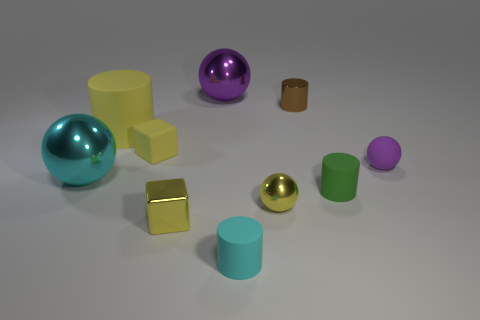The tiny metal block is what color?
Offer a terse response. Yellow. Is there a tiny object of the same color as the rubber block?
Give a very brief answer. Yes. The big metal thing that is on the right side of the metal object that is on the left side of the yellow block that is behind the large cyan metal ball is what shape?
Ensure brevity in your answer.  Sphere. What is the material of the object that is to the right of the small green rubber object?
Ensure brevity in your answer.  Rubber. There is a shiny ball that is right of the large thing that is behind the brown metal cylinder that is on the left side of the small purple sphere; what size is it?
Provide a short and direct response. Small. Do the brown cylinder and the purple ball to the right of the green cylinder have the same size?
Your response must be concise. Yes. There is a small sphere that is in front of the big cyan shiny thing; what color is it?
Make the answer very short. Yellow. What is the shape of the big object that is the same color as the small matte cube?
Make the answer very short. Cylinder. What shape is the cyan matte object to the right of the cyan sphere?
Your answer should be very brief. Cylinder. What number of yellow objects are rubber cylinders or tiny rubber spheres?
Your answer should be very brief. 1. 